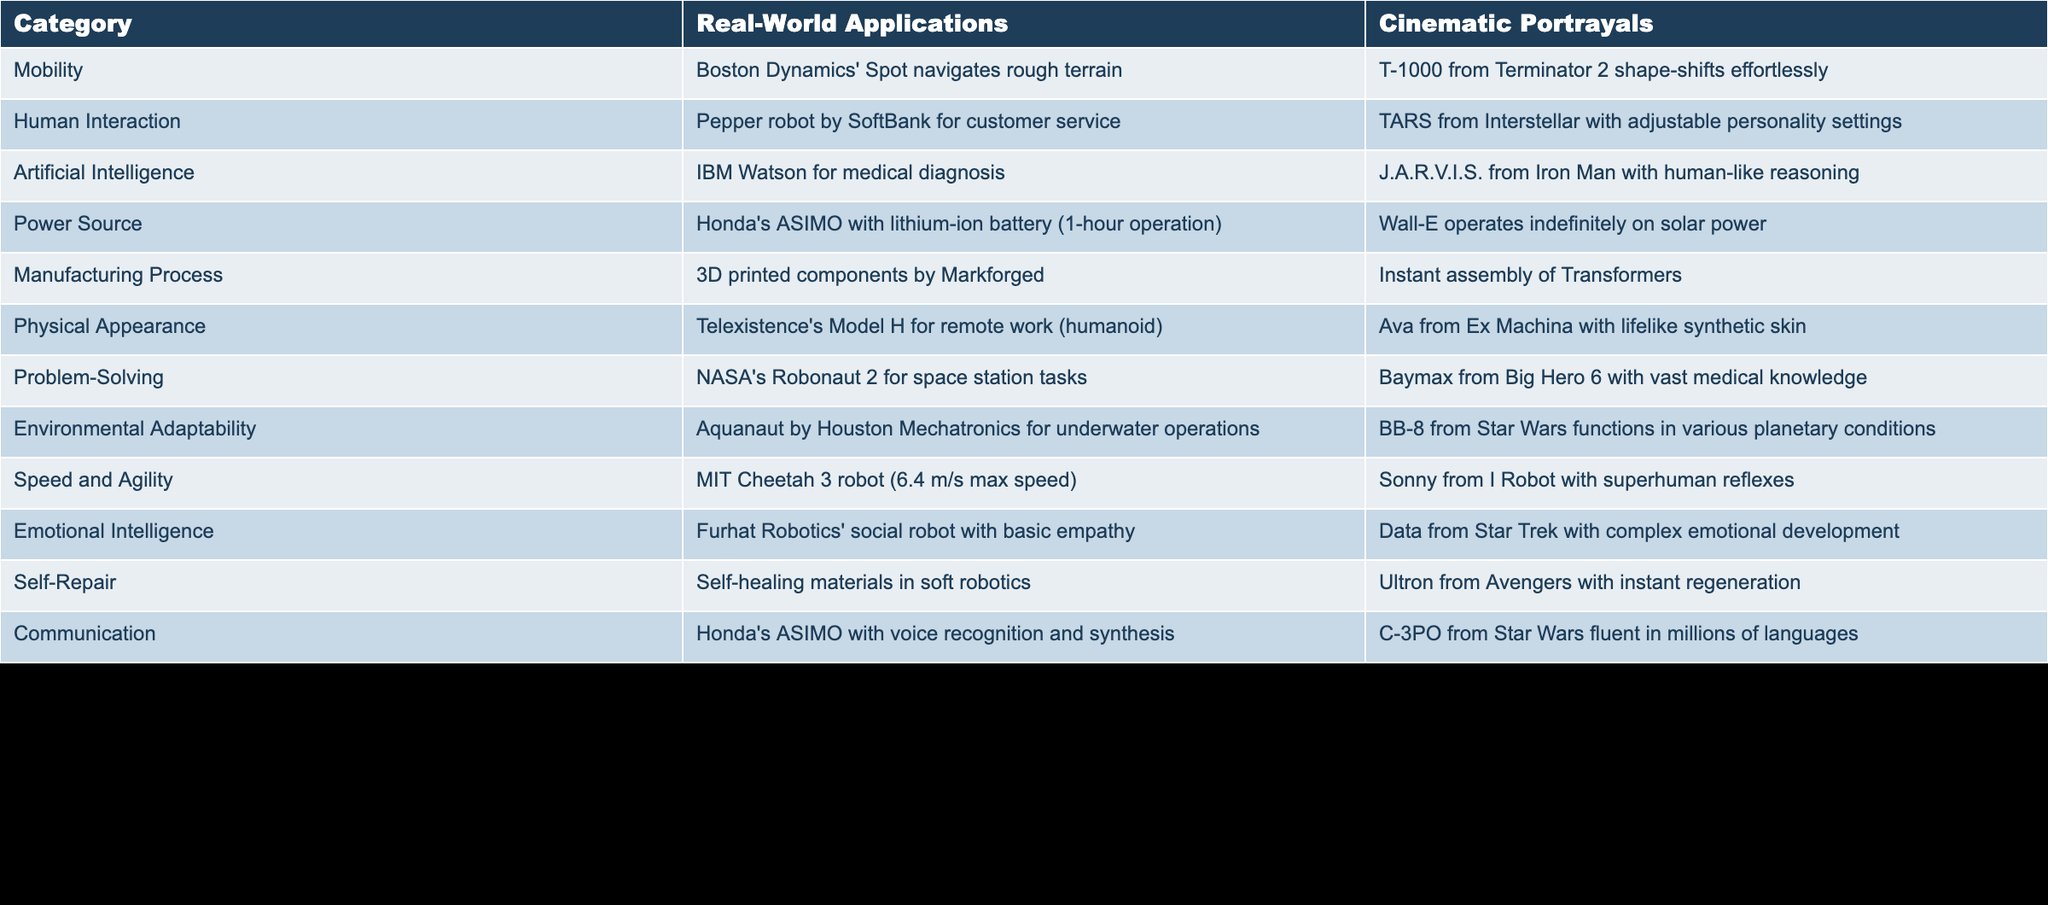What is the primary mobility method showcased in real-world applications? The table lists Boston Dynamics' Spot as navigating rough terrain under real-world applications for mobility. This shows a focus on practical, reliable movement systems, specifically designed for challenging environments.
Answer: Boston Dynamics' Spot Which robot is highlighted for emotional intelligence in cinematic portrayals? The table mentions Data from Star Trek as having complex emotional development in cinematic portrayals for emotional intelligence, indicating a portrayal of advanced, relatable emotional capabilities.
Answer: Data from Star Trek In terms of power source, which design operates indefinitely and which has a limited operation time? The table indicates Wall-E operates indefinitely on solar power while Honda's ASIMO has a lithium-ion battery with only 1-hour operation, showing a contrast between cinematic idealism and real-world limitations in power source designs.
Answer: Wall-E operates indefinitely; ASIMO has limited operation time What is the main problem-solving robot used in real-world applications? NASA's Robonaut 2 is presented as the main problem-solving robot working on space station tasks, showcasing the integration of advanced robotics in demanding environments for practical use.
Answer: NASA's Robonaut 2 Which robot from cinematic portrayals is known for superhuman reflexes, and how does this compare to the speed of the real-world application? The table shows that Sonny from I Robot is known for superhuman reflexes, while MIT Cheetah 3 has a max speed of 6.4 m/s. This reflects a significant exaggeration in cinematic portrayals compared to the capabilities of real-world robotics, which are impressive but within physical limitations.
Answer: Sonny from I Robot; MIT Cheetah 3 (6.4 m/s) How does the manufacturing process differ between real-world applications and cinematic portrayals? Real-world applications utilize 3D printed components by Markforged, indicating a gradual and practical approach to manufacturing, while cinematic references depict instant assembly of Transformers, emphasizing imaginative, fantastical capabilities unattainable in reality.
Answer: 3D printed components vs. instant assembly Is it true that both real-world and cinematic portrayals have robots designed for communication? The table confirms that both realms feature robots for communication, with ASIMO utilizing voice recognition and C-3PO being fluent in many languages, illustrating shared themes of communication yet diverging in technological aspects.
Answer: Yes What are the common features of robots showcased in environmental adaptability across both applications? Both Aquanaut, designed for underwater operations, and BB-8, which functions in various planetary conditions, illustrate adaptability to diverse environments, suggesting a common theme of versatility in robotics design featured in both real-world and cinematic scenarios.
Answer: Versatility in diverse environments 